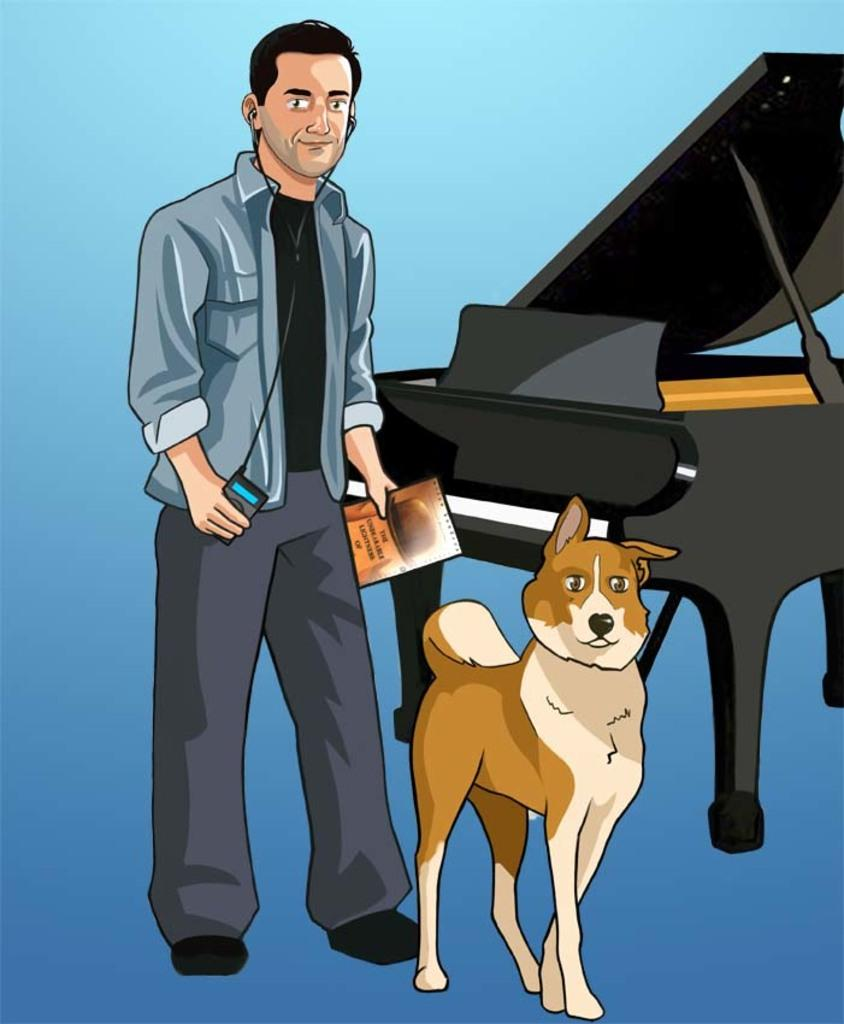What is the main subject of the image? There is a person in the image. What is the person doing in the image? The person is standing. What objects is the person holding in the image? The person is holding a mobile and a book. What animal is present beside the person in the image? There is a dog beside the person in the image. What can be seen in the background of the image? There is a grand piano in the background of the image. What type of bells can be heard ringing in the image? There are no bells present in the image, and therefore no sound can be heard. Is the room in the image quiet or noisy? The image does not provide any information about the noise level in the room. 